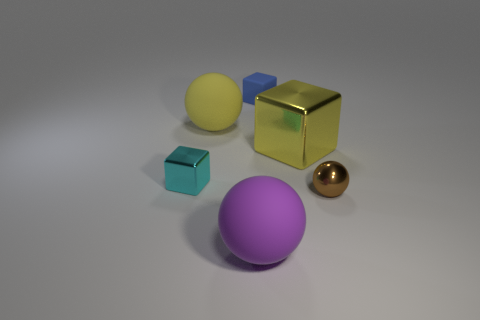Subtract all small blocks. How many blocks are left? 1 Subtract 3 spheres. How many spheres are left? 0 Subtract all yellow balls. How many balls are left? 2 Subtract all brown matte objects. Subtract all tiny brown metal objects. How many objects are left? 5 Add 3 tiny metal balls. How many tiny metal balls are left? 4 Add 2 brown shiny things. How many brown shiny things exist? 3 Add 1 tiny yellow rubber cylinders. How many objects exist? 7 Subtract 0 purple cylinders. How many objects are left? 6 Subtract all brown spheres. Subtract all yellow cylinders. How many spheres are left? 2 Subtract all brown balls. How many cyan blocks are left? 1 